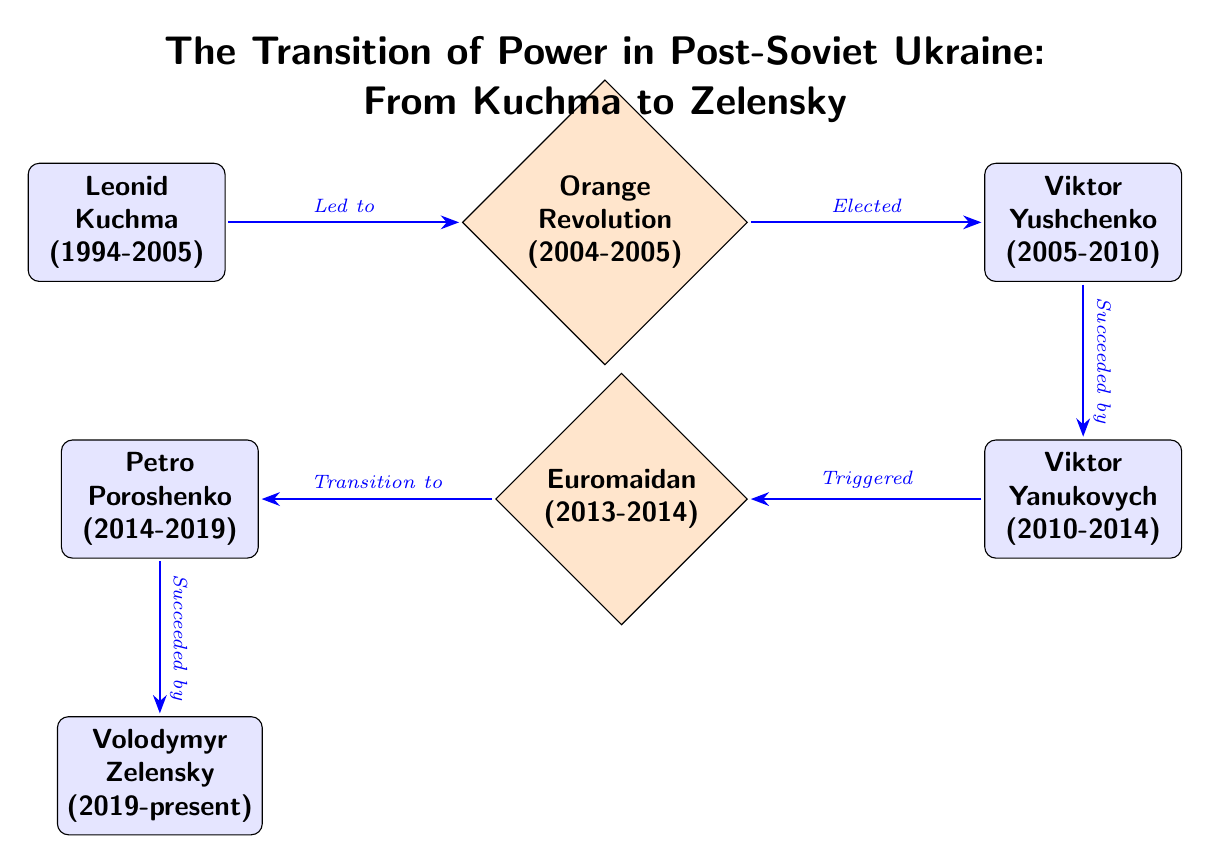What was the first presidency in the diagram? The diagram starts with Leonid Kuchma as the first President of Ukraine from 1994 to 2005.
Answer: Leonid Kuchma Which event was triggered by Viktor Yanukovych? The arrow coming from Viktor Yanukovych points to the Euromaidan event, indicating that his presidency triggered it.
Answer: Euromaidan Who succeeded Petro Poroshenko? The diagram shows an arrow from Petro Poroshenko to Volodymyr Zelensky, indicating that Zelensky succeeded Poroshenko.
Answer: Volodymyr Zelensky How many presidents are shown in the diagram? Counting the boxes representing presidents, there are four presidents depicted: Kuchma, Yushchenko, Yanukovych, and Poroshenko.
Answer: 4 What event led to the election of Viktor Yushchenko? The diagram links the Orange Revolution to the election of Viktor Yushchenko, indicating that the revolution was the cause for his election.
Answer: Orange Revolution What was the transition that followed Euromaidan? According to the diagram, the transition that followed Euromaidan was to Petro Poroshenko, where the protests led to a new president.
Answer: Transition to Petro Poroshenko Who was the president during the Orange Revolution? The diagram indicates that during the time of the Orange Revolution, Viktor Yushchenko was not yet president but engaged in the political turmoil leading to his election post-revolution.
Answer: Viktor Yushchenko What type of events are represented in the diagram? The diagram contains both events and presidents, with events marked as diamonds and presidents as boxes, indicating both political events and leadership changes.
Answer: Events and Presidents 